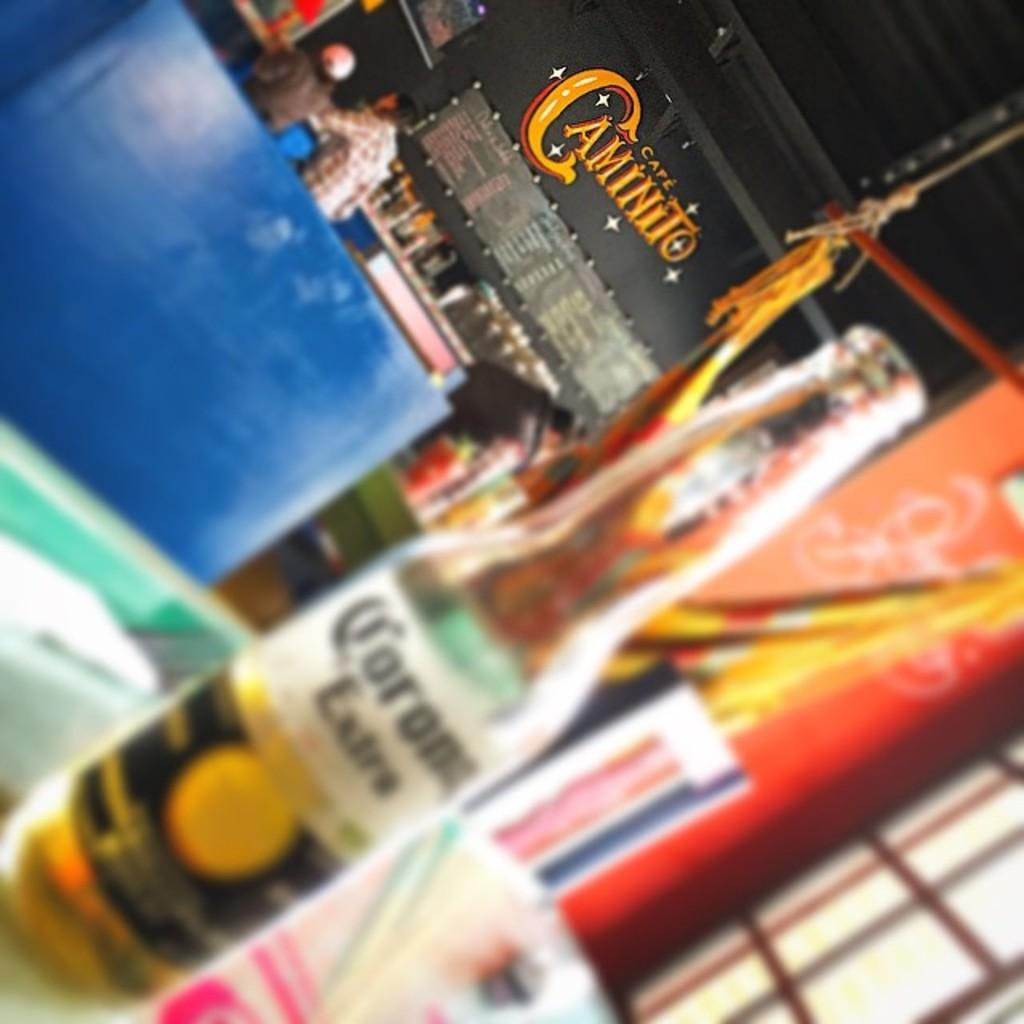<image>
Relay a brief, clear account of the picture shown. A bottle of corona sitting on a table at cafe caminito. 